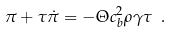Convert formula to latex. <formula><loc_0><loc_0><loc_500><loc_500>\pi + \tau \dot { \pi } = - \Theta c _ { b } ^ { 2 } \rho \gamma \tau \ .</formula> 